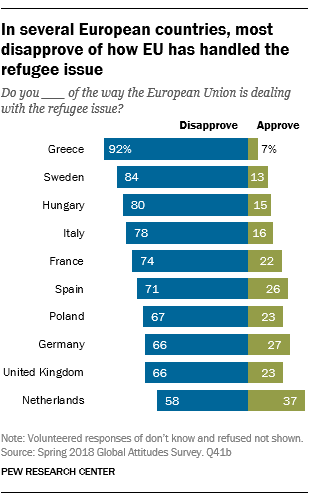Outline some significant characteristics in this image. According to a recent survey in Greece, 92% of the population disapproves of something. In how many cases does the sum of the largest two 'Approve' bar values exceed the value of the smallest 'Disapprove' bar value? 